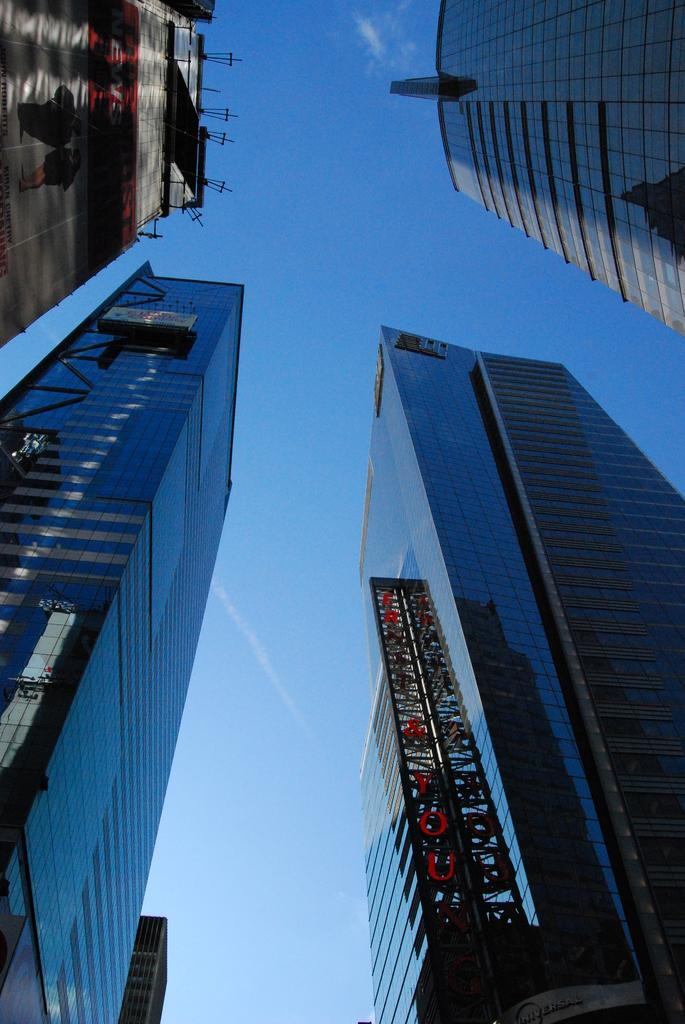What type of structures can be seen in the image? There are buildings in the image. What type of juice is being served in the image? There is no juice present in the image; it only features buildings. Are the people in the image having trouble walking? There are no people visible in the image, so it is impossible to determine if they are having trouble walking. 